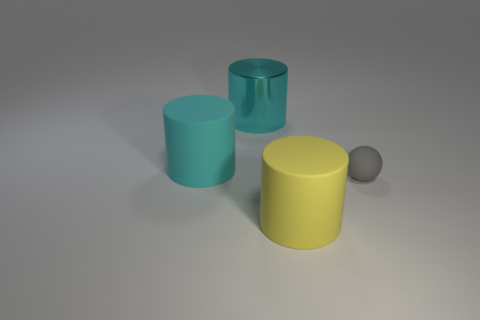What can you tell me about the lighting in the scene? The lighting in the scene is soft and seems to be coming from the top left, creating gentle shadows on the right sides of the objects and on the surface. It gives the scene a calm, even illumination without harsh contrasts. 